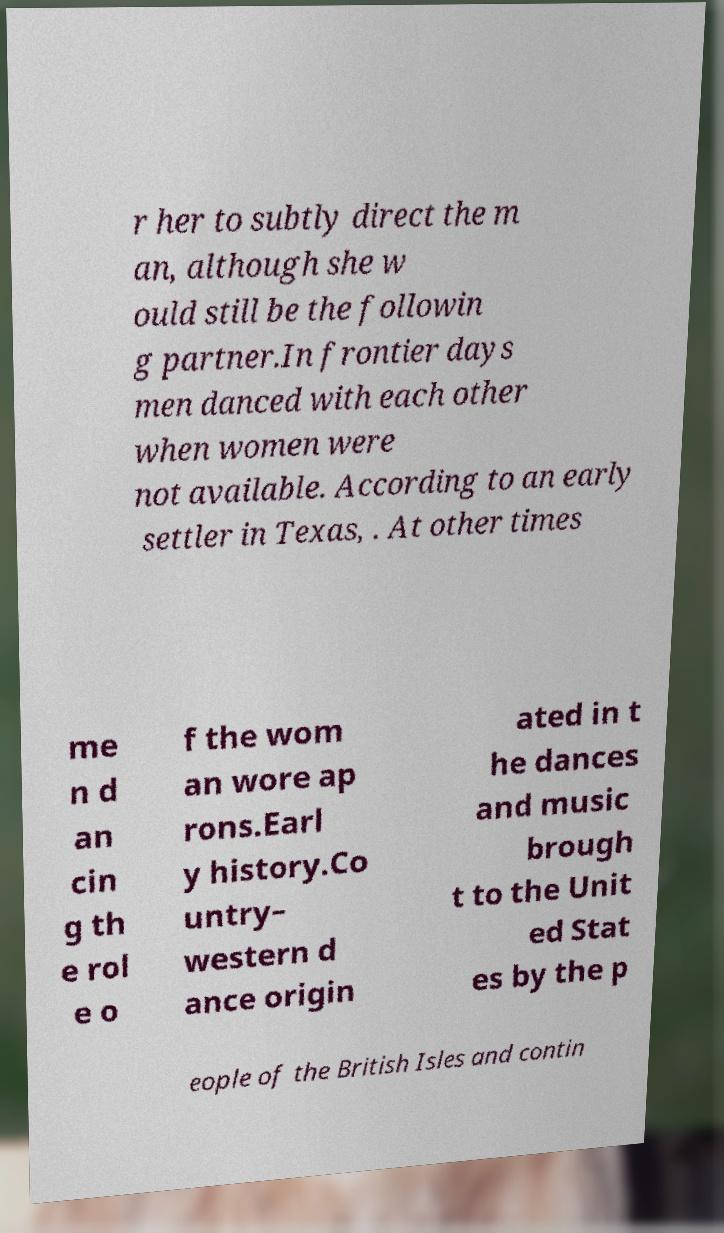For documentation purposes, I need the text within this image transcribed. Could you provide that? r her to subtly direct the m an, although she w ould still be the followin g partner.In frontier days men danced with each other when women were not available. According to an early settler in Texas, . At other times me n d an cin g th e rol e o f the wom an wore ap rons.Earl y history.Co untry– western d ance origin ated in t he dances and music brough t to the Unit ed Stat es by the p eople of the British Isles and contin 